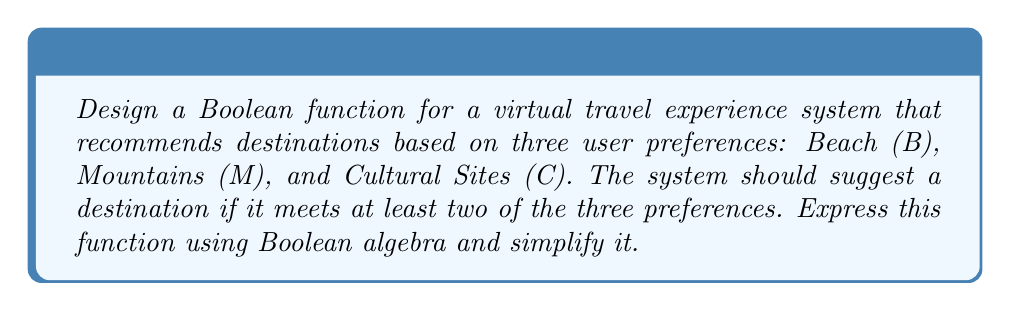Could you help me with this problem? Let's approach this step-by-step:

1) First, we need to define our Boolean function. Let's call it $F(B, M, C)$. The function should output 1 (true) if at least two of the inputs are 1, and 0 (false) otherwise.

2) We can express this using the sum-of-products form:

   $$F(B, M, C) = BM\bar{C} + BC\bar{M} + MC\bar{B} + BMC$$

3) This expression covers all cases where at least two inputs are 1:
   - $BM\bar{C}$: Beach and Mountains, but not Cultural Sites
   - $BC\bar{M}$: Beach and Cultural Sites, but not Mountains
   - $MC\bar{B}$: Mountains and Cultural Sites, but not Beach
   - $BMC$: All three preferences

4) To simplify this expression, we can use Boolean algebra laws:

   $$\begin{align}
   F(B, M, C) &= BM\bar{C} + BC\bar{M} + MC\bar{B} + BMC \\
   &= BM(\bar{C} + C) + BC(\bar{M} + M) + MC(\bar{B} + B) \\
   &= BM + BC + MC
   \end{align}$$

5) This simplified form, $BM + BC + MC$, is known as the symmetric function $S_2^3(B, M, C)$.

6) For a person who cannot travel due to health problems, this virtual travel system allows them to input their preferences and receive tailored destination recommendations without leaving home.
Answer: $F(B, M, C) = BM + BC + MC$ 